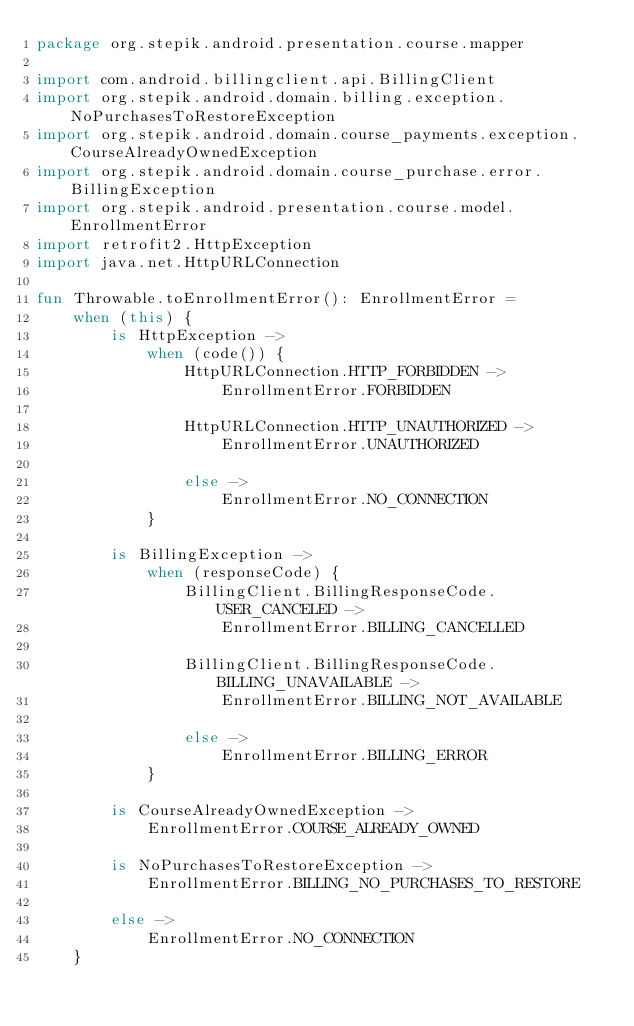Convert code to text. <code><loc_0><loc_0><loc_500><loc_500><_Kotlin_>package org.stepik.android.presentation.course.mapper

import com.android.billingclient.api.BillingClient
import org.stepik.android.domain.billing.exception.NoPurchasesToRestoreException
import org.stepik.android.domain.course_payments.exception.CourseAlreadyOwnedException
import org.stepik.android.domain.course_purchase.error.BillingException
import org.stepik.android.presentation.course.model.EnrollmentError
import retrofit2.HttpException
import java.net.HttpURLConnection

fun Throwable.toEnrollmentError(): EnrollmentError =
    when (this) {
        is HttpException ->
            when (code()) {
                HttpURLConnection.HTTP_FORBIDDEN ->
                    EnrollmentError.FORBIDDEN

                HttpURLConnection.HTTP_UNAUTHORIZED ->
                    EnrollmentError.UNAUTHORIZED

                else ->
                    EnrollmentError.NO_CONNECTION
            }

        is BillingException ->
            when (responseCode) {
                BillingClient.BillingResponseCode.USER_CANCELED ->
                    EnrollmentError.BILLING_CANCELLED

                BillingClient.BillingResponseCode.BILLING_UNAVAILABLE ->
                    EnrollmentError.BILLING_NOT_AVAILABLE

                else ->
                    EnrollmentError.BILLING_ERROR
            }

        is CourseAlreadyOwnedException ->
            EnrollmentError.COURSE_ALREADY_OWNED

        is NoPurchasesToRestoreException ->
            EnrollmentError.BILLING_NO_PURCHASES_TO_RESTORE

        else ->
            EnrollmentError.NO_CONNECTION
    }</code> 